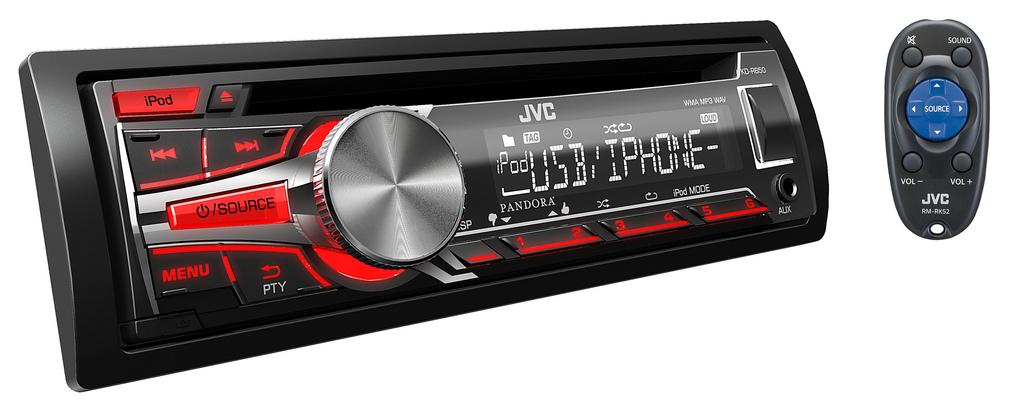<image>
Provide a brief description of the given image. A car radio player with an iPod plugged in with USB/iPhone features. 